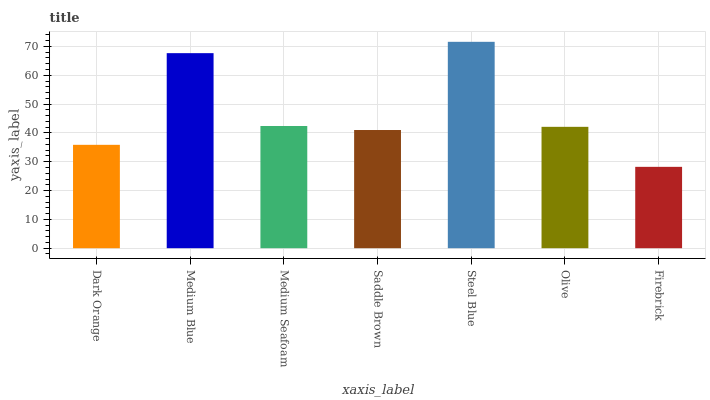Is Medium Blue the minimum?
Answer yes or no. No. Is Medium Blue the maximum?
Answer yes or no. No. Is Medium Blue greater than Dark Orange?
Answer yes or no. Yes. Is Dark Orange less than Medium Blue?
Answer yes or no. Yes. Is Dark Orange greater than Medium Blue?
Answer yes or no. No. Is Medium Blue less than Dark Orange?
Answer yes or no. No. Is Olive the high median?
Answer yes or no. Yes. Is Olive the low median?
Answer yes or no. Yes. Is Steel Blue the high median?
Answer yes or no. No. Is Steel Blue the low median?
Answer yes or no. No. 